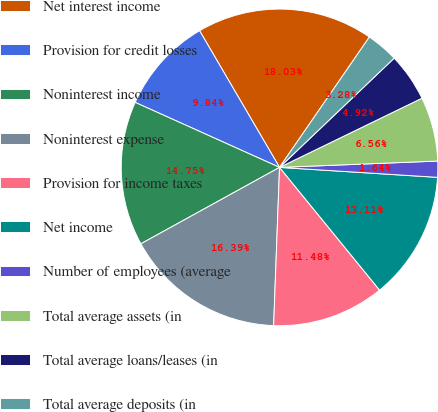<chart> <loc_0><loc_0><loc_500><loc_500><pie_chart><fcel>Net interest income<fcel>Provision for credit losses<fcel>Noninterest income<fcel>Noninterest expense<fcel>Provision for income taxes<fcel>Net income<fcel>Number of employees (average<fcel>Total average assets (in<fcel>Total average loans/leases (in<fcel>Total average deposits (in<nl><fcel>18.03%<fcel>9.84%<fcel>14.75%<fcel>16.39%<fcel>11.48%<fcel>13.11%<fcel>1.64%<fcel>6.56%<fcel>4.92%<fcel>3.28%<nl></chart> 